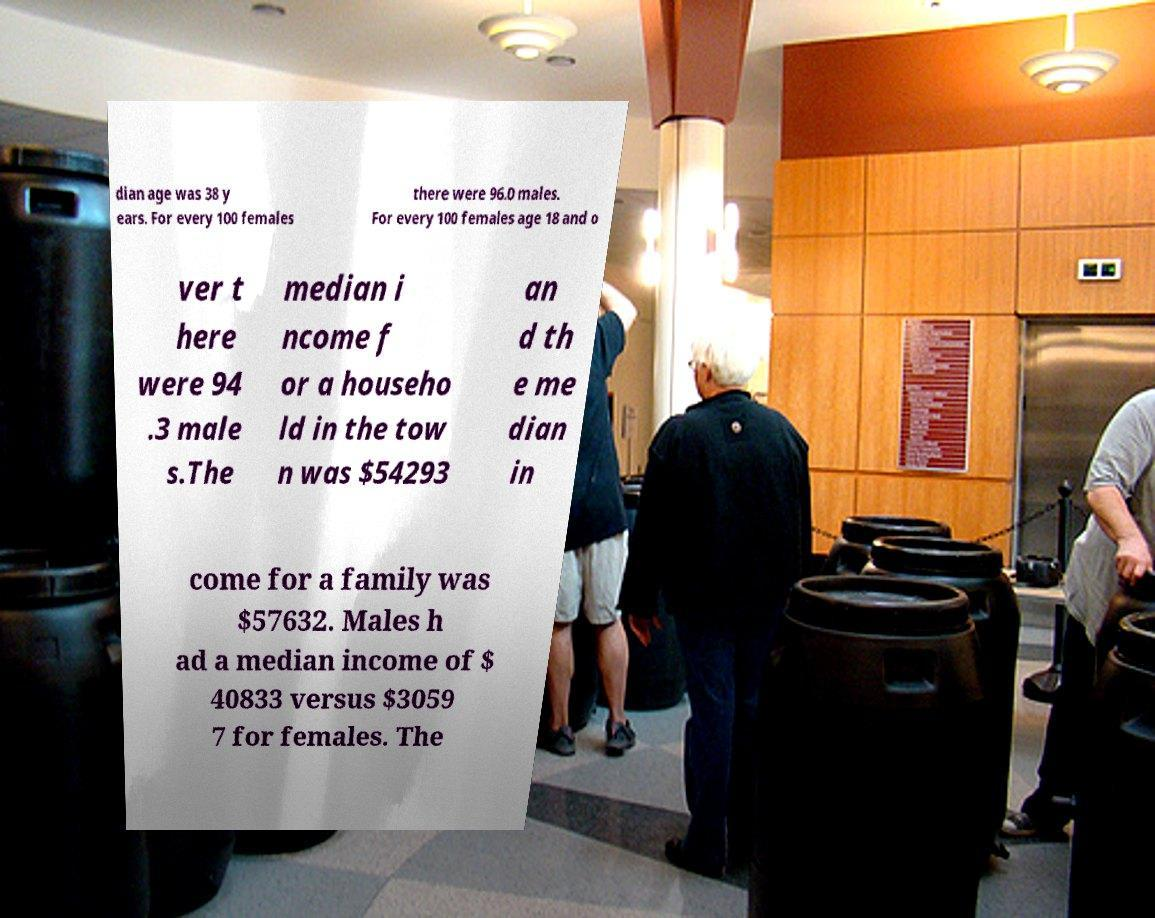Could you assist in decoding the text presented in this image and type it out clearly? dian age was 38 y ears. For every 100 females there were 96.0 males. For every 100 females age 18 and o ver t here were 94 .3 male s.The median i ncome f or a househo ld in the tow n was $54293 an d th e me dian in come for a family was $57632. Males h ad a median income of $ 40833 versus $3059 7 for females. The 